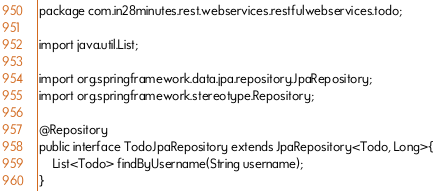Convert code to text. <code><loc_0><loc_0><loc_500><loc_500><_Java_>package com.in28minutes.rest.webservices.restfulwebservices.todo;

import java.util.List;

import org.springframework.data.jpa.repository.JpaRepository;
import org.springframework.stereotype.Repository;

@Repository
public interface TodoJpaRepository extends JpaRepository<Todo, Long>{
	List<Todo> findByUsername(String username);
}</code> 